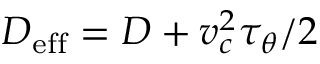<formula> <loc_0><loc_0><loc_500><loc_500>D _ { e f f } = D + v _ { c } ^ { 2 } \tau _ { \theta } / 2</formula> 